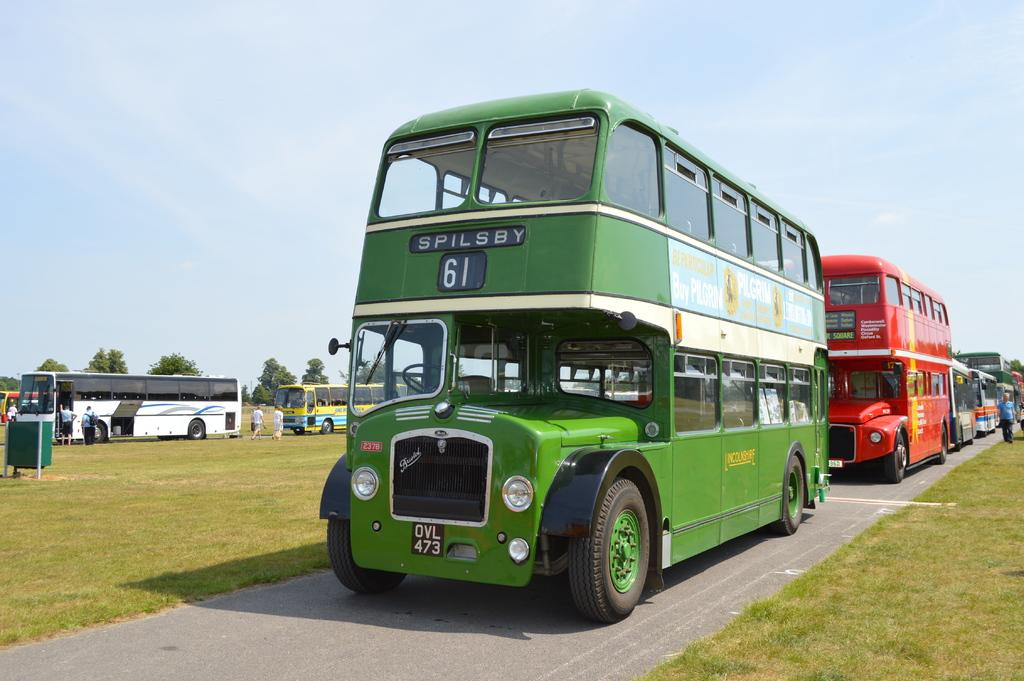Provide a one-sentence caption for the provided image. A green double decker bus going to spilsby and marked number 61 infront of a red double decker bus. 